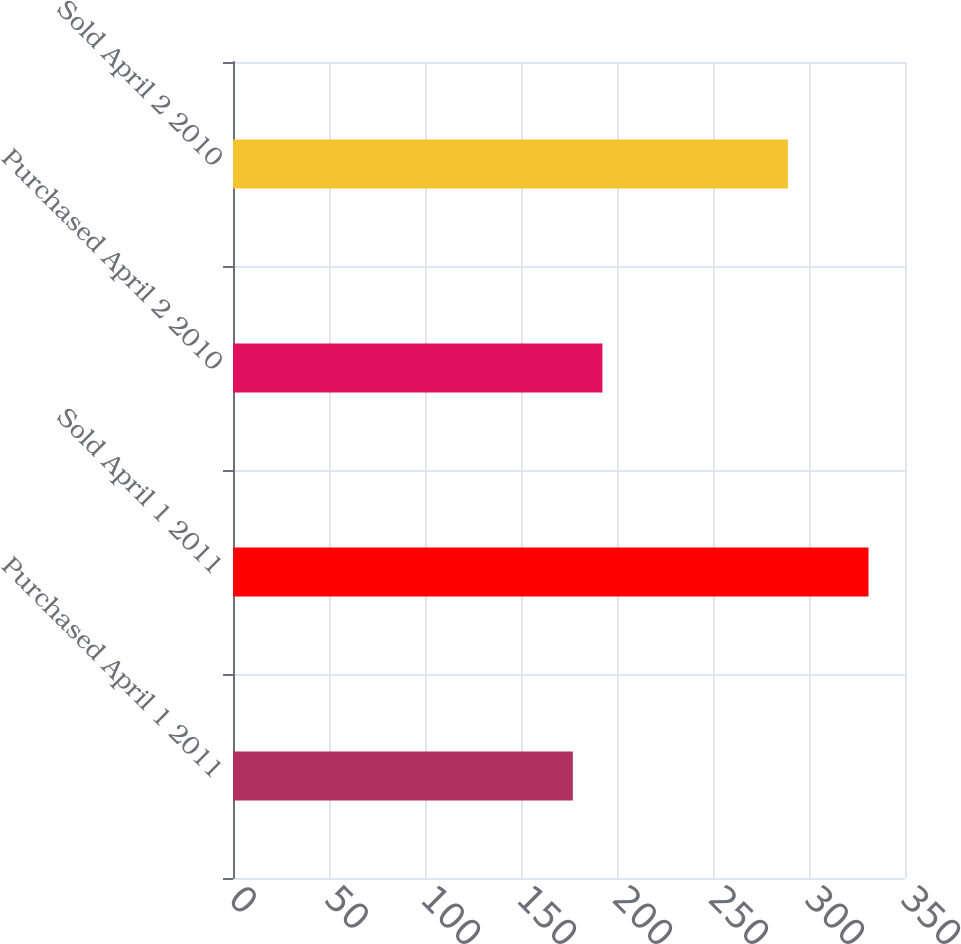Convert chart to OTSL. <chart><loc_0><loc_0><loc_500><loc_500><bar_chart><fcel>Purchased April 1 2011<fcel>Sold April 1 2011<fcel>Purchased April 2 2010<fcel>Sold April 2 2010<nl><fcel>177<fcel>331<fcel>192.4<fcel>289<nl></chart> 